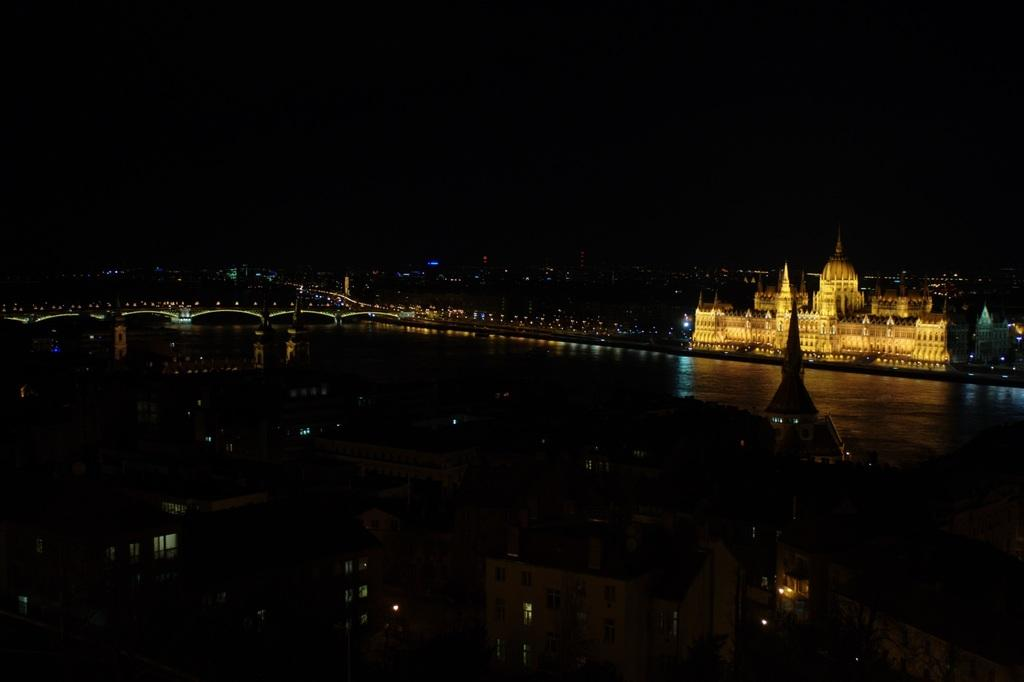What type of structures can be seen in the image? There are buildings and a palace in the image. What architectural feature is present in the image? There is a bridge in the image. What natural element is depicted in the image? There is a river in the image. What type of lighting is visible in the image? Electric lights are visible in the image. What part of the natural environment is visible in the image? The sky is visible in the image. Where is the cemetery located in the image? There is no cemetery present in the image. What type of chickens can be seen walking on the bridge in the image? There are no chickens present in the image, and the bridge is not depicted as having any animals walking on it. 